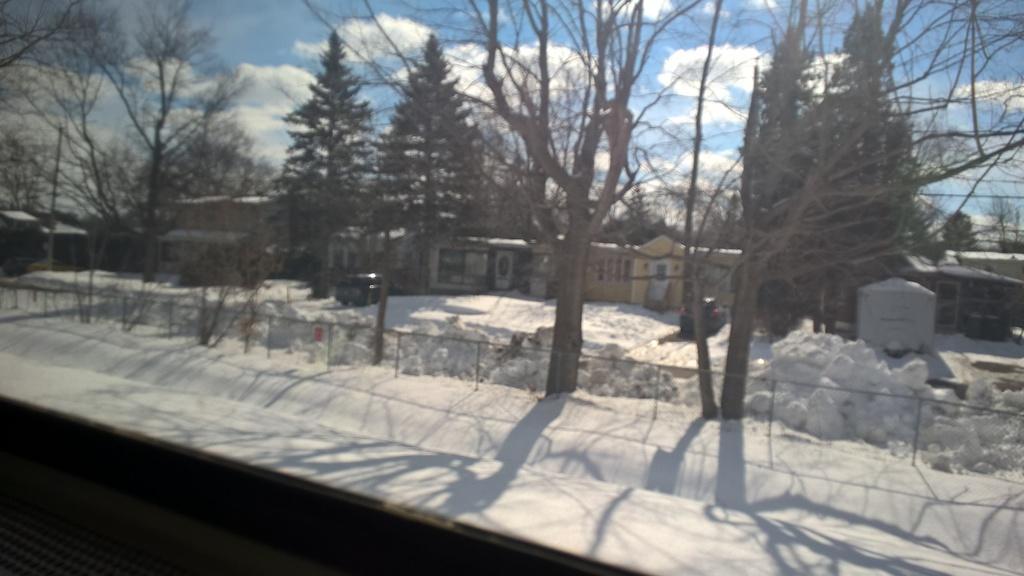Describe this image in one or two sentences. In this image we can see snow, fence, trees, vehicles, houses, and a pole. In the background there is sky with clouds. 